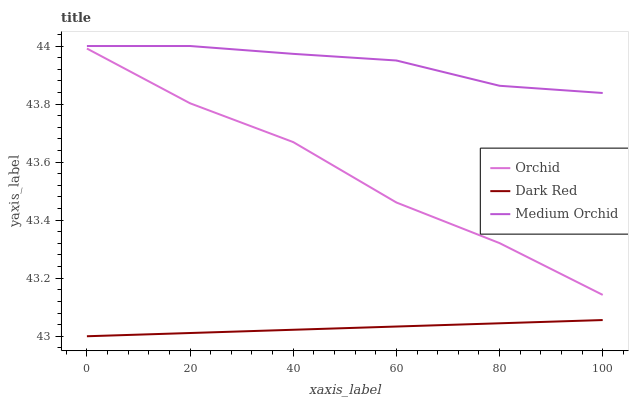Does Orchid have the minimum area under the curve?
Answer yes or no. No. Does Orchid have the maximum area under the curve?
Answer yes or no. No. Is Medium Orchid the smoothest?
Answer yes or no. No. Is Medium Orchid the roughest?
Answer yes or no. No. Does Orchid have the lowest value?
Answer yes or no. No. Does Orchid have the highest value?
Answer yes or no. No. Is Orchid less than Medium Orchid?
Answer yes or no. Yes. Is Medium Orchid greater than Orchid?
Answer yes or no. Yes. Does Orchid intersect Medium Orchid?
Answer yes or no. No. 